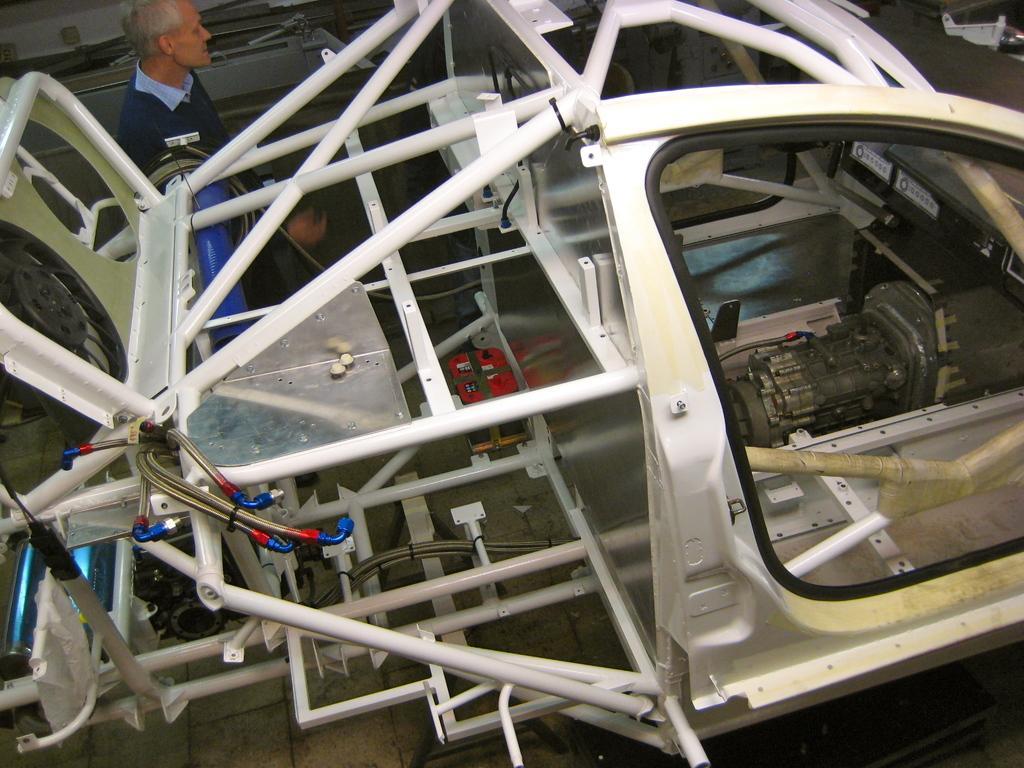Describe this image in one or two sentences. It seems like parts of vehicle in the foreground of the image. In the background, we can see a person and some metal objects. At the bottom of the image, we can see the floor. 